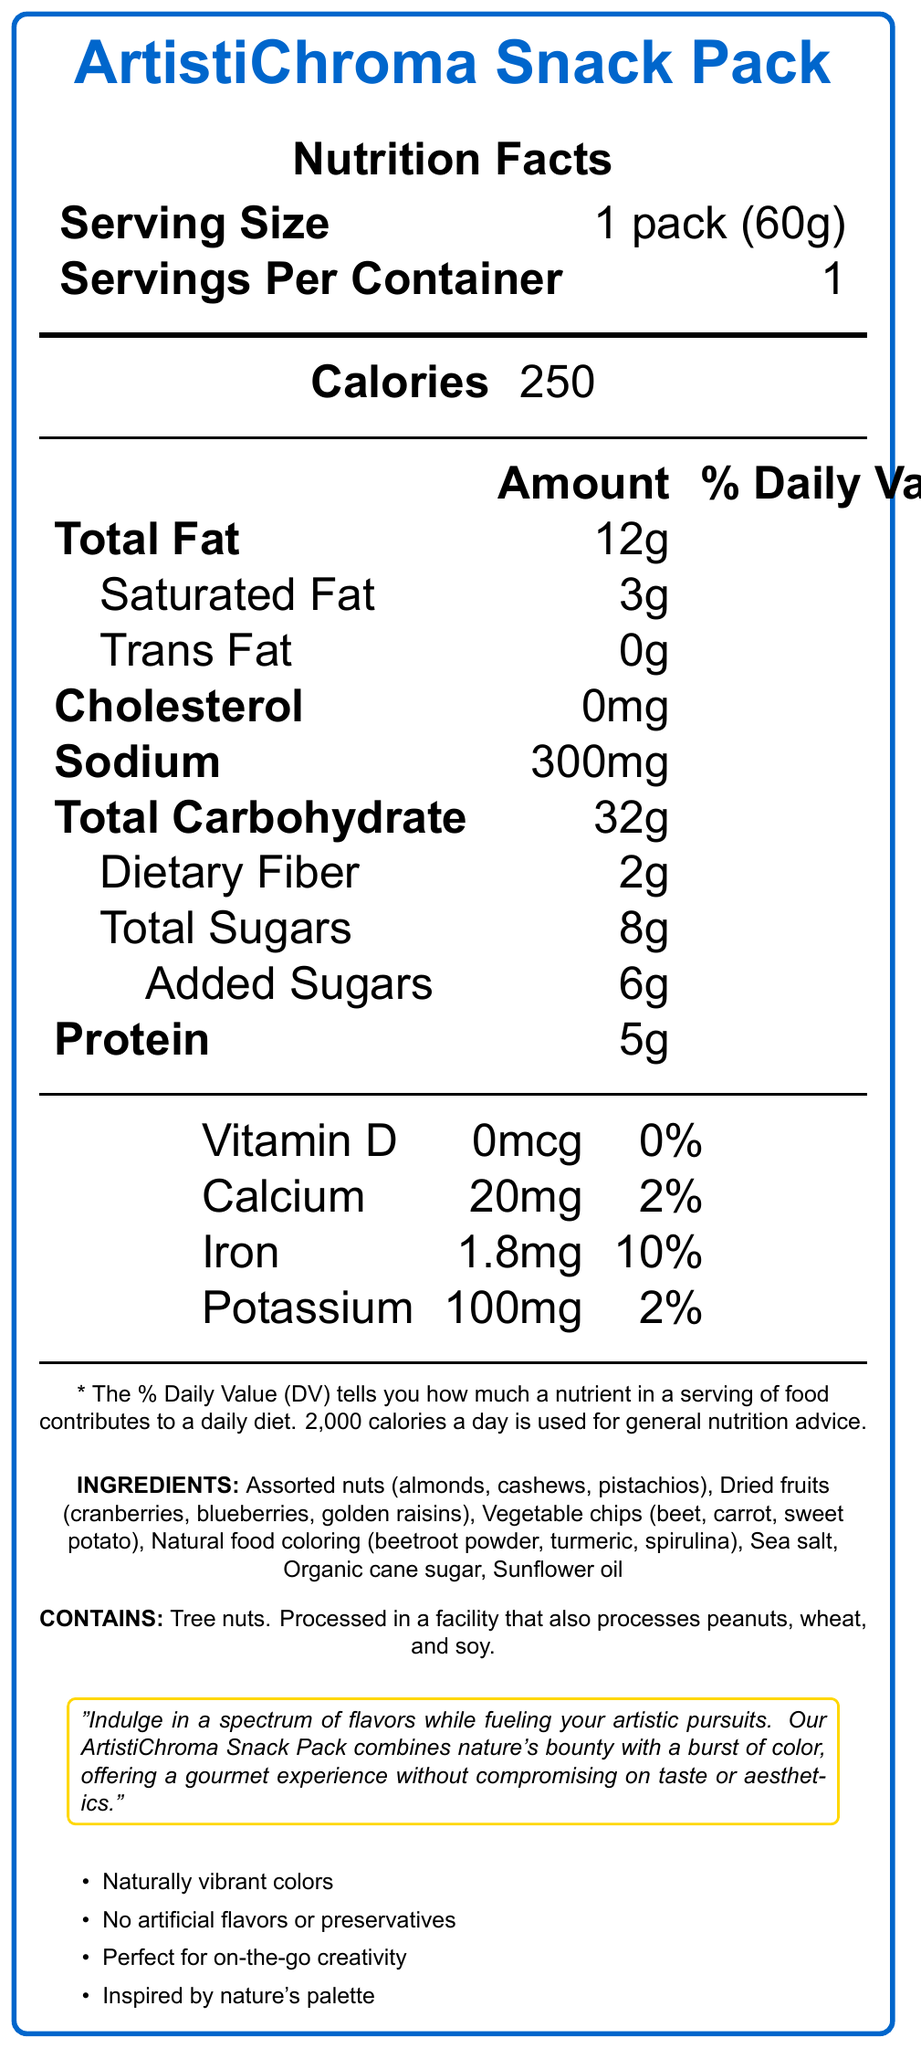What is the serving size of the ArtistiChroma Snack Pack? The serving size is listed as "1 pack (60g)" directly in the nutritional facts section.
Answer: 1 pack (60g) How many calories are in one serving of this snack pack? The nutritional facts indicate that there are 250 calories per serving.
Answer: 250 What percentage of the Daily Value for sodium does the snack pack contain? The document shows that the sodium content is 300mg, which is 13% of the Daily Value.
Answer: 13% How much saturated fat is in the snack pack? The saturated fat content is listed as 3g in the nutritional facts section.
Answer: 3g What are the total carbohydrates in one serving of the snack pack? The nutritional facts state that there are 32g of total carbohydrates per serving.
Answer: 32g How many grams of dietary fiber are in the snack pack? The snack pack contains 2g of dietary fiber, as stated in the document.
Answer: 2g What food colorings are used in this snack pack? A. Artificial colorings B. Beetroot powder C. Turmeric D. Spirulina The document lists natural food coloring ingredients, which are beetroot powder, turmeric, and spirulina.
Answer: B, C, D What is the iron content in the nutritional facts? A. 1.8mg B. 2mg C. 3mg D. 1mg The iron content is listed as 1.8mg.
Answer: A Does this product contain any trans fat? The nutritional facts indicate that the product contains 0g of trans fat.
Answer: No Is the product processed in a facility that processes peanuts? The document mentions that the snack pack is processed in a facility that also processes peanuts, wheat, and soy.
Answer: Yes Summarize the main idea of the document. The document provides detailed nutritional facts and ingredient details for the ArtistiChroma Snack Pack. It emphasizes the use of natural food colorings like beetroot powder, turmeric, and spirulina and includes specific marketing claims such as "Naturally vibrant colors" and "No artificial flavors or preservatives." The document also points out that the product is suitable for on-the-go creativity and is inspired by nature's palette.
Answer: The ArtistiChroma Snack Pack is a gourmet, art-inspired snack with naturally vibrant colors from natural ingredients, highlighted by comprehensive nutritional information and marketing claims emphasizing natural and high-quality content. How much potassium is in one serving of the snack pack? The document lists the potassium content as 100mg.
Answer: 100mg Is calcium content significant in the snack pack? A. Yes B. No C. Maybe D. Cannot determine The calcium content is only 20mg, which is 2% of the Daily Value, indicating it is not significant.
Answer: B. No What types of nuts are included in the ingredients? The ingredients section lists almonds, cashews, and pistachios as the types of nuts in the snack pack.
Answer: Almonds, cashews, pistachios How many grams of added sugars are in the snack pack? The nutritional facts state that there are 6g of added sugars.
Answer: 6g Does the document mention a specific utility or benefit related to artistic pursuits? The artist note mentions that the snack pack is designed to "fuel your artistic pursuits" and combines nature's bounty with a burst of color.
Answer: Yes What is the exact sodium amount in the snack pack? The document states that the sodium content is 300mg.
Answer: 300mg How much Vitamin D is provided by the ArtistiChroma Snack Pack? The document indicates that there is 0mcg of Vitamin D in the snack pack.
Answer: 0mcg What is the total fat percentage of the Daily Value in the snack pack? The document lists the total fat amount as 12g, which is 15% of the Daily Value.
Answer: 15% Which ingredients in the snack pack are used for natural food coloring? Beetroot powder, spirulina, turmeric The ingredient list specifically names beetroot powder, turmeric, and spirulina as natural food colorings.
Answer: Beetroot powder, turmeric, spirulina Can this snack pack be considered a significant source of protein? The document mentions that the snack pack contains 5g of protein but does not specify what constitutes a "significant source" of protein in the context provided.
Answer: Not enough information 